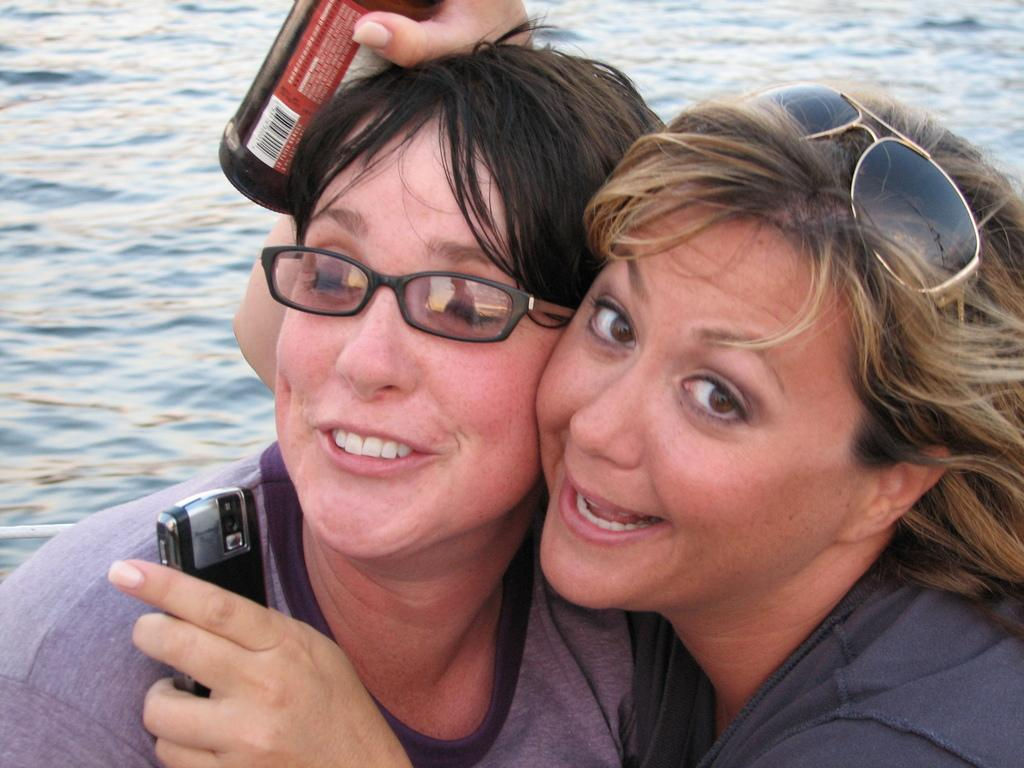How many ladies are in the image? There are two ladies in the image. What is the lady on the right holding in her hand? The lady on the right is holding a bottle and a mobile. What can be seen in the background of the image? There is water visible in the background of the image. Can you tell me how high the ladies are jumping in the image? There is no indication in the image that the ladies are jumping, so it cannot be determined from the picture. 